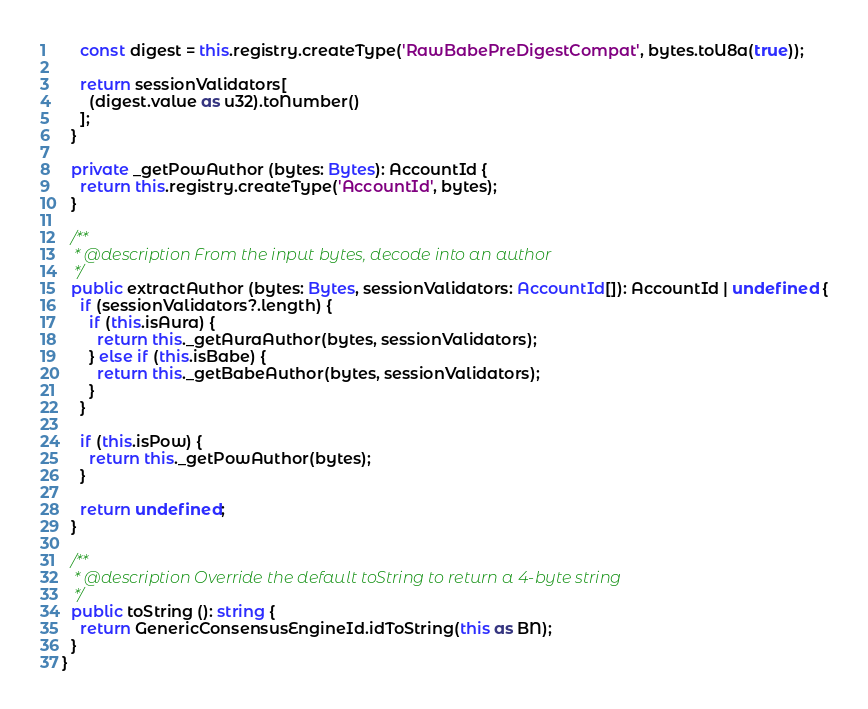Convert code to text. <code><loc_0><loc_0><loc_500><loc_500><_TypeScript_>    const digest = this.registry.createType('RawBabePreDigestCompat', bytes.toU8a(true));

    return sessionValidators[
      (digest.value as u32).toNumber()
    ];
  }

  private _getPowAuthor (bytes: Bytes): AccountId {
    return this.registry.createType('AccountId', bytes);
  }

  /**
   * @description From the input bytes, decode into an author
   */
  public extractAuthor (bytes: Bytes, sessionValidators: AccountId[]): AccountId | undefined {
    if (sessionValidators?.length) {
      if (this.isAura) {
        return this._getAuraAuthor(bytes, sessionValidators);
      } else if (this.isBabe) {
        return this._getBabeAuthor(bytes, sessionValidators);
      }
    }

    if (this.isPow) {
      return this._getPowAuthor(bytes);
    }

    return undefined;
  }

  /**
   * @description Override the default toString to return a 4-byte string
   */
  public toString (): string {
    return GenericConsensusEngineId.idToString(this as BN);
  }
}
</code> 